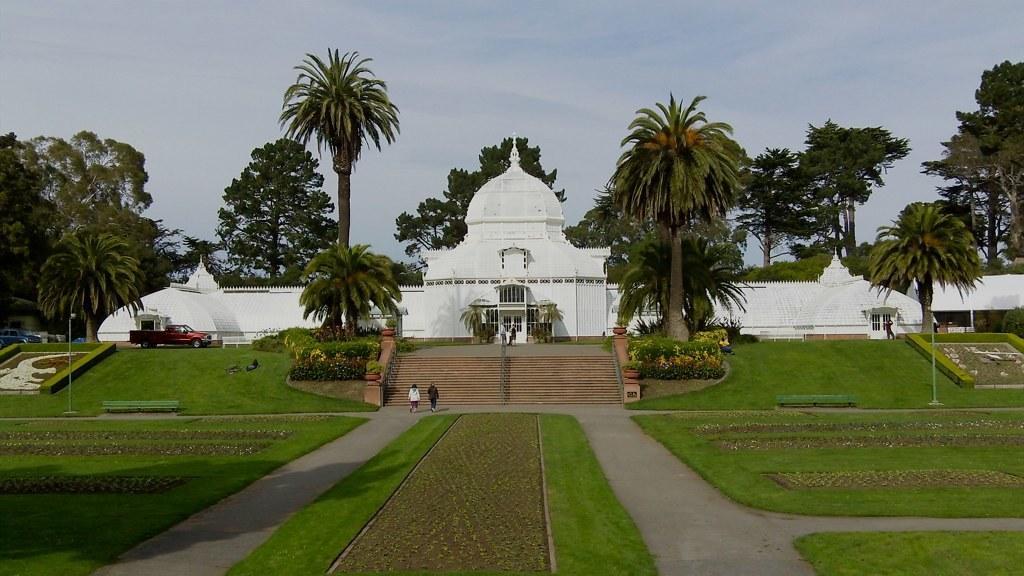Describe this image in one or two sentences. In this image we can see we can see a building. In front of the building we can see the vehicles, trees, plants, persons and stairs. In front of the stairs we can see the grass, persons, plants and poles. Behind the building we can see a group of trees. At the top we can see the sky. 